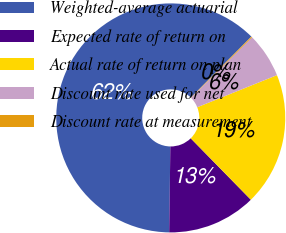<chart> <loc_0><loc_0><loc_500><loc_500><pie_chart><fcel>Weighted-average actuarial<fcel>Expected rate of return on<fcel>Actual rate of return on plan<fcel>Discount rate used for net<fcel>Discount rate at measurement<nl><fcel>62.21%<fcel>12.55%<fcel>18.76%<fcel>6.34%<fcel>0.13%<nl></chart> 